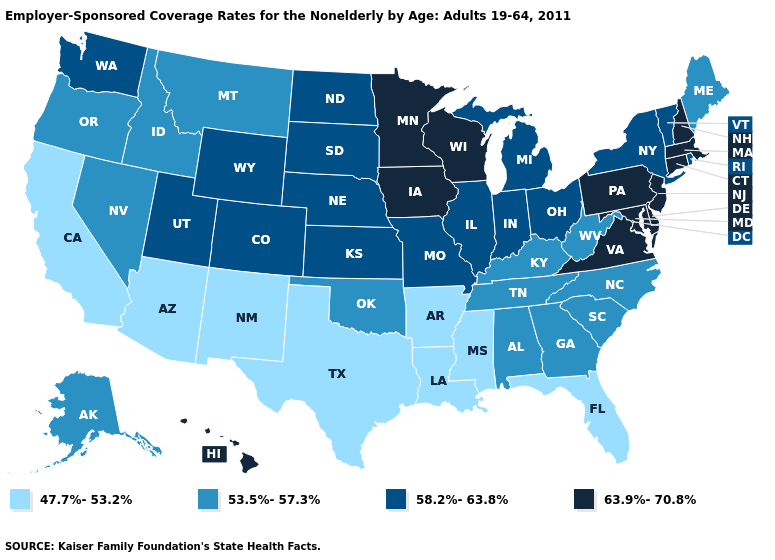What is the value of Hawaii?
Short answer required. 63.9%-70.8%. What is the value of Delaware?
Write a very short answer. 63.9%-70.8%. Name the states that have a value in the range 58.2%-63.8%?
Quick response, please. Colorado, Illinois, Indiana, Kansas, Michigan, Missouri, Nebraska, New York, North Dakota, Ohio, Rhode Island, South Dakota, Utah, Vermont, Washington, Wyoming. Name the states that have a value in the range 53.5%-57.3%?
Answer briefly. Alabama, Alaska, Georgia, Idaho, Kentucky, Maine, Montana, Nevada, North Carolina, Oklahoma, Oregon, South Carolina, Tennessee, West Virginia. Among the states that border Mississippi , does Arkansas have the highest value?
Be succinct. No. What is the highest value in the West ?
Write a very short answer. 63.9%-70.8%. Among the states that border Wyoming , which have the lowest value?
Quick response, please. Idaho, Montana. What is the highest value in the Northeast ?
Answer briefly. 63.9%-70.8%. Name the states that have a value in the range 47.7%-53.2%?
Keep it brief. Arizona, Arkansas, California, Florida, Louisiana, Mississippi, New Mexico, Texas. What is the lowest value in the USA?
Keep it brief. 47.7%-53.2%. Among the states that border New Mexico , which have the lowest value?
Concise answer only. Arizona, Texas. Does Minnesota have the same value as Virginia?
Quick response, please. Yes. How many symbols are there in the legend?
Write a very short answer. 4. Name the states that have a value in the range 47.7%-53.2%?
Be succinct. Arizona, Arkansas, California, Florida, Louisiana, Mississippi, New Mexico, Texas. How many symbols are there in the legend?
Quick response, please. 4. 